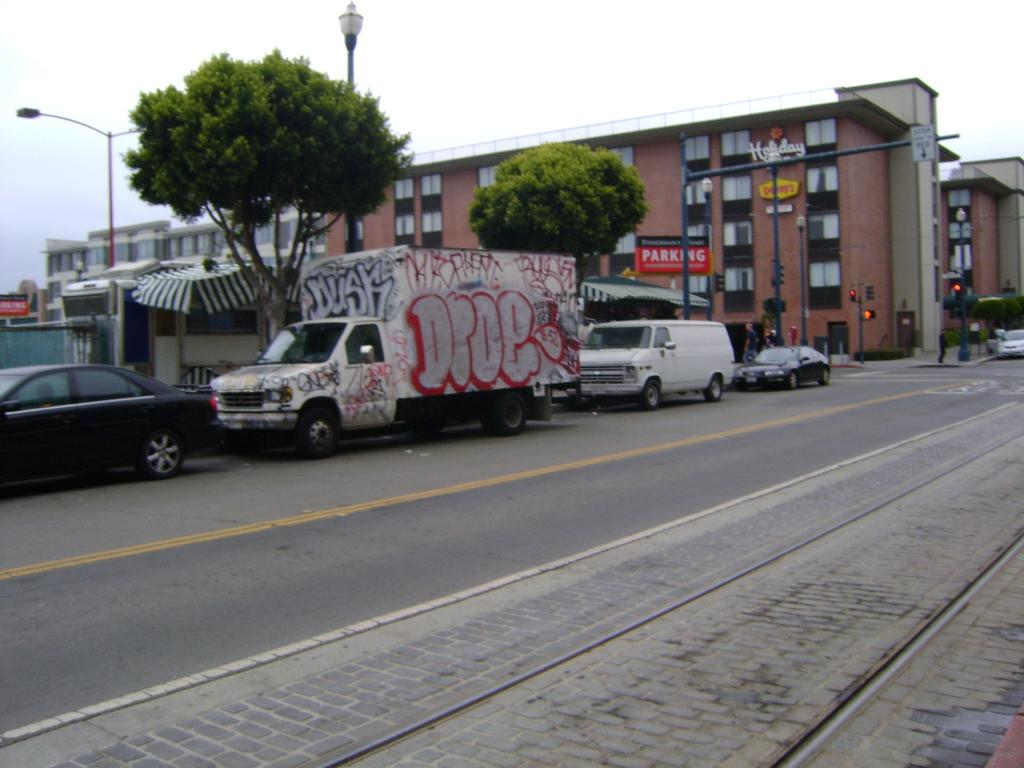What can be seen on the road in the image? There are vehicles on the road in the image. What type of natural elements are present in the image? There are trees in the image. What type of temporary shelter is visible in the image? There is a tent in the image. What type of structures can be seen in the image? There are buildings in the image. What architectural features are present in the image? There are windows, traffic signal poles, light poles, and street lights in the image. What type of advertising is present in the image? There are hoardings in the image. What is visible in the sky in the image? There are clouds in the sky in the image. Where is the cemetery located in the image? There is no cemetery present in the image. What type of terrain can be seen near the coast in the image? There is no coast present in the image. How many cattle are grazing in the image? There are no cattle present in the image. 